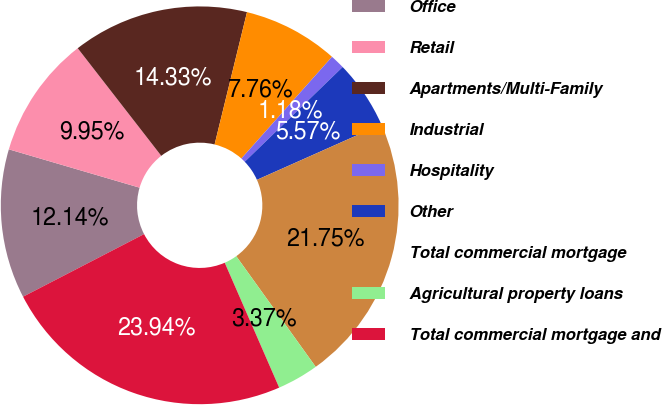Convert chart to OTSL. <chart><loc_0><loc_0><loc_500><loc_500><pie_chart><fcel>Office<fcel>Retail<fcel>Apartments/Multi-Family<fcel>Industrial<fcel>Hospitality<fcel>Other<fcel>Total commercial mortgage<fcel>Agricultural property loans<fcel>Total commercial mortgage and<nl><fcel>12.14%<fcel>9.95%<fcel>14.33%<fcel>7.76%<fcel>1.18%<fcel>5.57%<fcel>21.75%<fcel>3.37%<fcel>23.94%<nl></chart> 